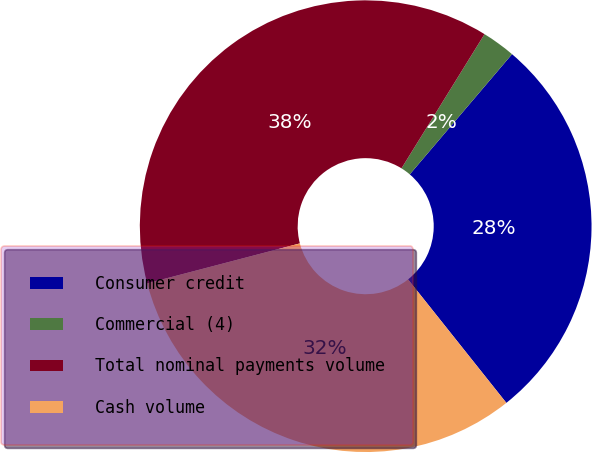<chart> <loc_0><loc_0><loc_500><loc_500><pie_chart><fcel>Consumer credit<fcel>Commercial (4)<fcel>Total nominal payments volume<fcel>Cash volume<nl><fcel>28.08%<fcel>2.4%<fcel>37.89%<fcel>31.63%<nl></chart> 